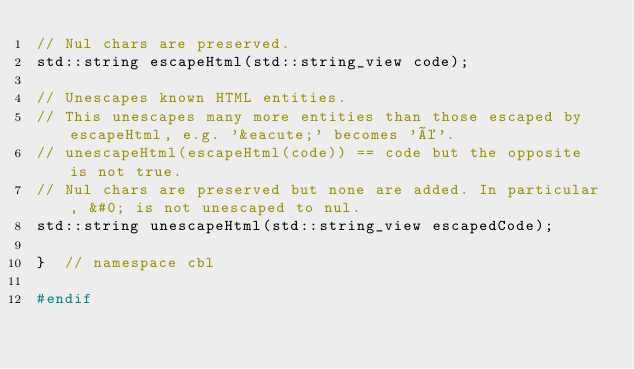Convert code to text. <code><loc_0><loc_0><loc_500><loc_500><_C_>// Nul chars are preserved.
std::string escapeHtml(std::string_view code);

// Unescapes known HTML entities.
// This unescapes many more entities than those escaped by escapeHtml, e.g. '&eacute;' becomes 'é'.
// unescapeHtml(escapeHtml(code)) == code but the opposite is not true.
// Nul chars are preserved but none are added. In particular, &#0; is not unescaped to nul.
std::string unescapeHtml(std::string_view escapedCode);

}  // namespace cbl

#endif
</code> 